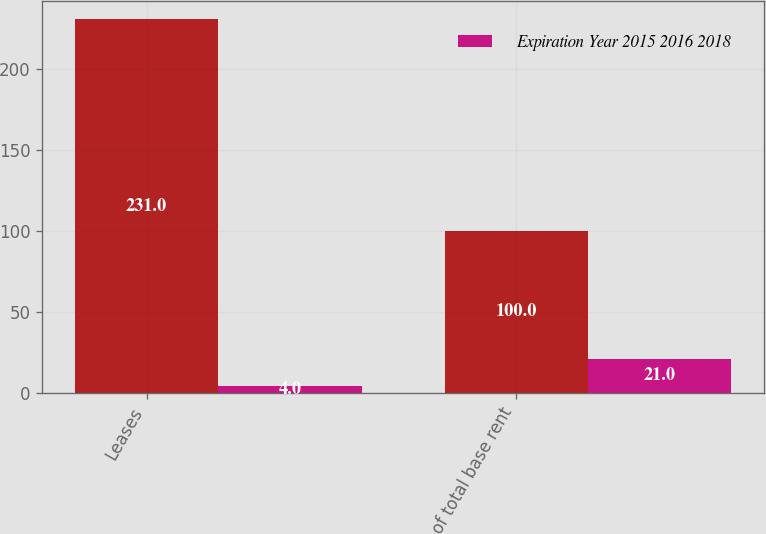Convert chart. <chart><loc_0><loc_0><loc_500><loc_500><stacked_bar_chart><ecel><fcel>Leases<fcel>of total base rent<nl><fcel>nan<fcel>231<fcel>100<nl><fcel>Expiration Year 2015 2016 2018<fcel>4<fcel>21<nl></chart> 